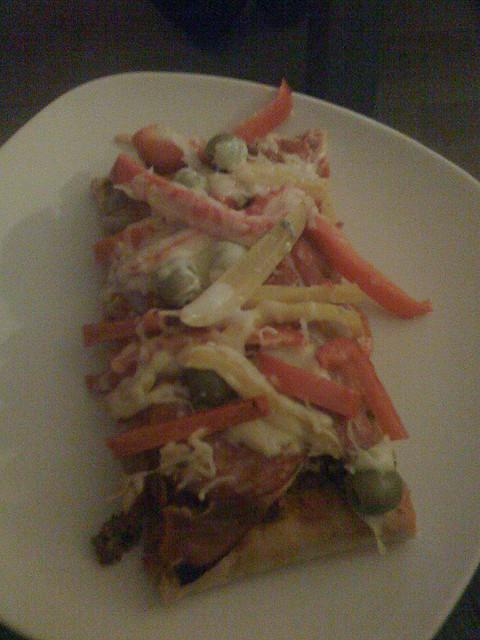The toppings are primarily from what food group?

Choices:
A) meat
B) fruit
C) vegetable
D) grain vegetable 